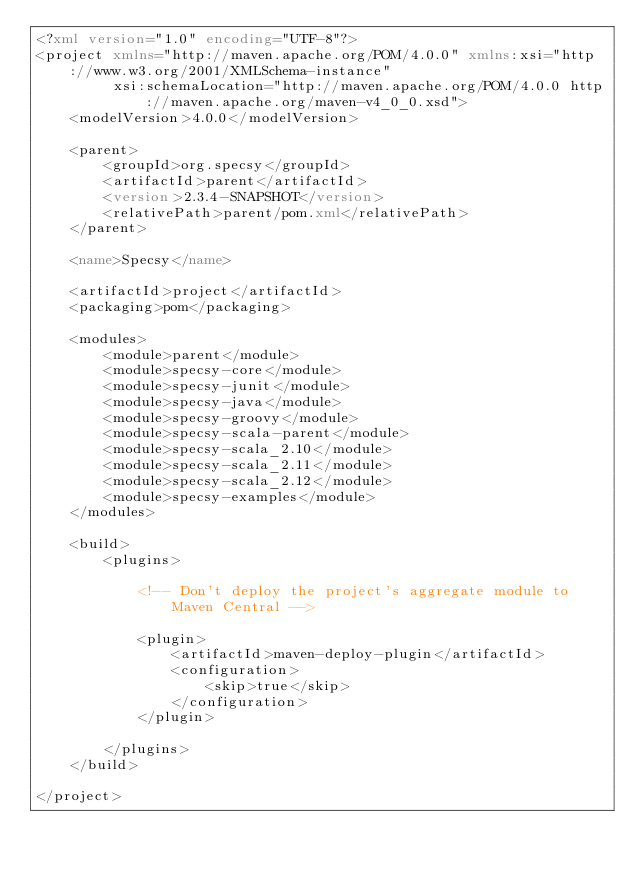<code> <loc_0><loc_0><loc_500><loc_500><_XML_><?xml version="1.0" encoding="UTF-8"?>
<project xmlns="http://maven.apache.org/POM/4.0.0" xmlns:xsi="http://www.w3.org/2001/XMLSchema-instance"
         xsi:schemaLocation="http://maven.apache.org/POM/4.0.0 http://maven.apache.org/maven-v4_0_0.xsd">
    <modelVersion>4.0.0</modelVersion>

    <parent>
        <groupId>org.specsy</groupId>
        <artifactId>parent</artifactId>
        <version>2.3.4-SNAPSHOT</version>
        <relativePath>parent/pom.xml</relativePath>
    </parent>

    <name>Specsy</name>

    <artifactId>project</artifactId>
    <packaging>pom</packaging>

    <modules>
        <module>parent</module>
        <module>specsy-core</module>
        <module>specsy-junit</module>
        <module>specsy-java</module>
        <module>specsy-groovy</module>
        <module>specsy-scala-parent</module>
        <module>specsy-scala_2.10</module>
        <module>specsy-scala_2.11</module>
        <module>specsy-scala_2.12</module>
        <module>specsy-examples</module>
    </modules>

    <build>
        <plugins>

            <!-- Don't deploy the project's aggregate module to Maven Central -->

            <plugin>
                <artifactId>maven-deploy-plugin</artifactId>
                <configuration>
                    <skip>true</skip>
                </configuration>
            </plugin>

        </plugins>
    </build>

</project>
</code> 